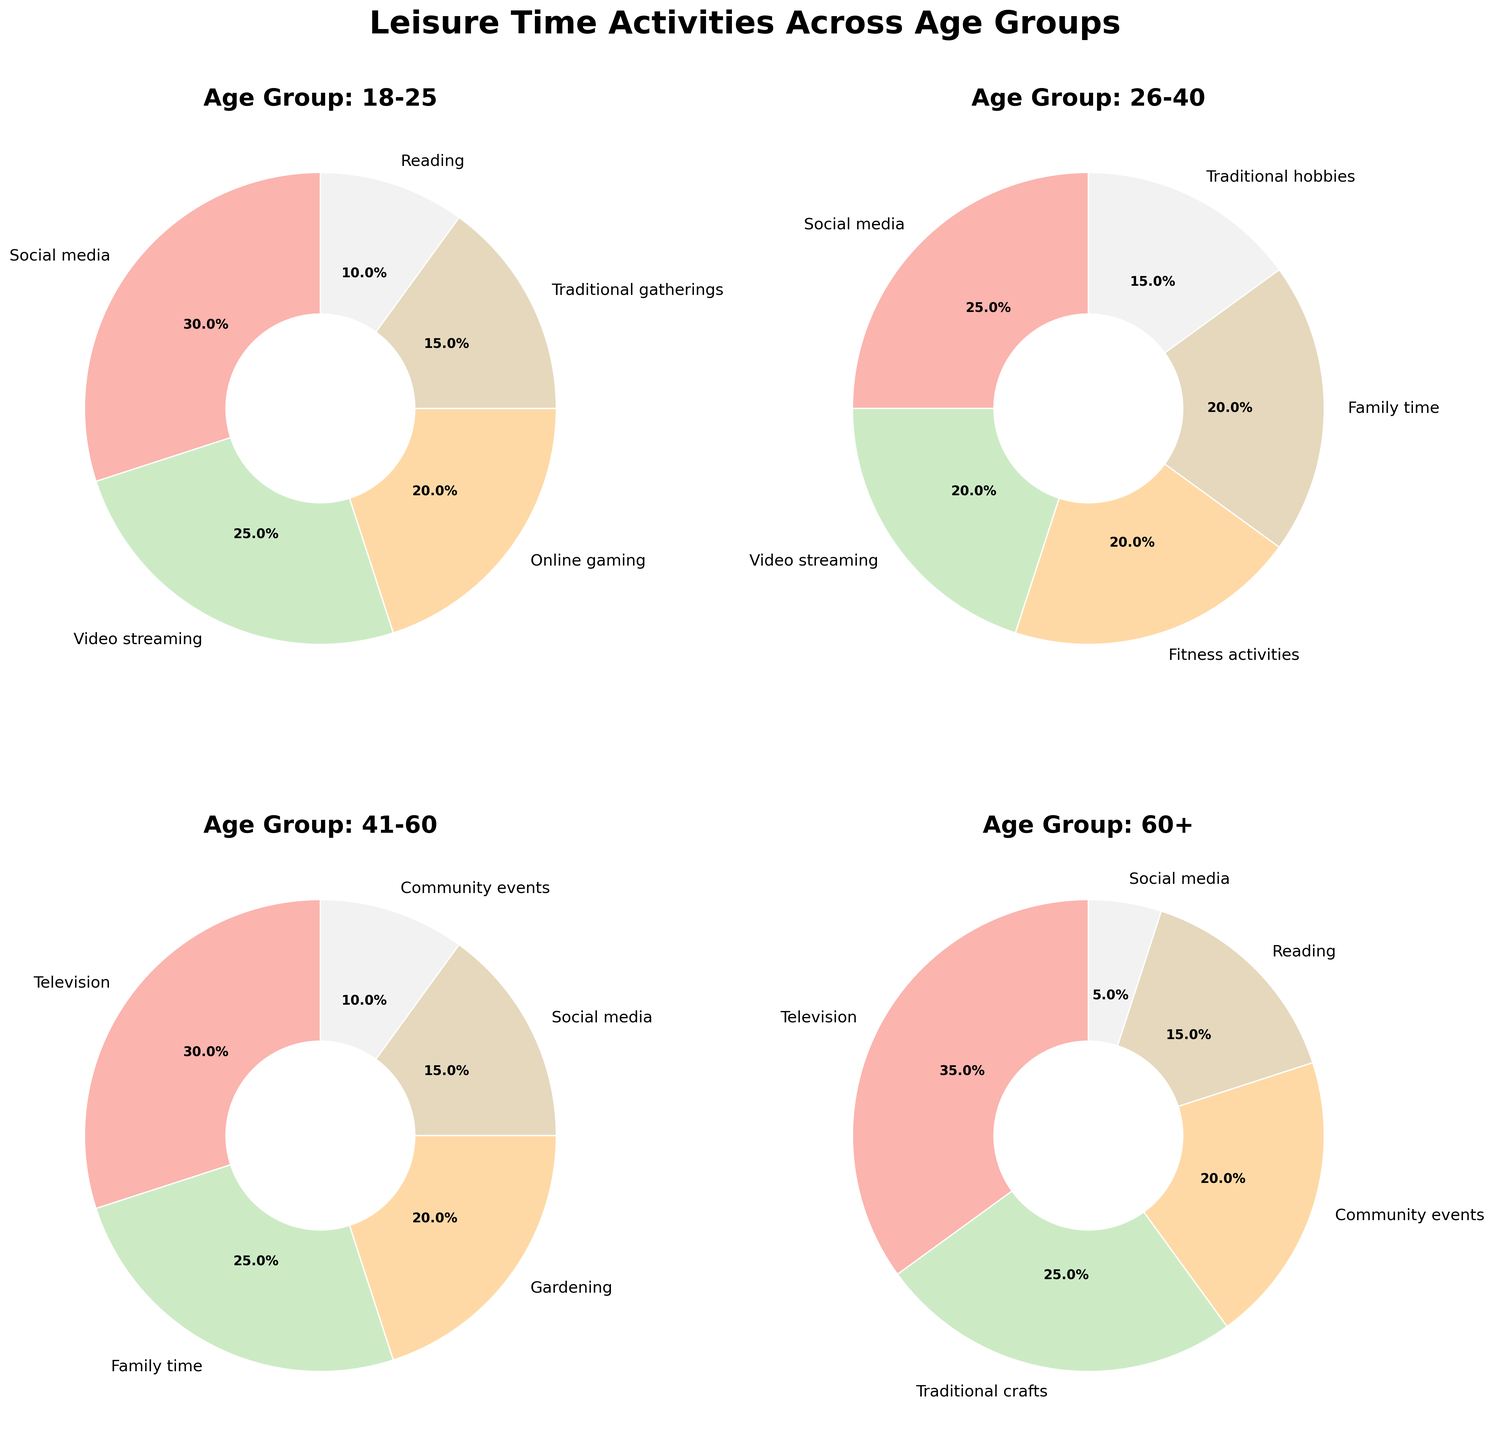Which age group spends the highest percentage of their leisure time on social media? By comparing the percentages of social media usage across the different age groups (18-25: 30%, 26-40: 25%, 41-60: 15%, 60+: 5%), it is clear that the 18-25 age group has the highest percentage.
Answer: 18-25 What is the combined percentage of leisure time spent on family time by 26-40 and 41-60 age groups? Adding the percentages for family time from both age groups (26-40: 20%, 41-60: 25%) gives a total of 45%.
Answer: 45% Which activity has the largest slice in the pie chart for the 60+ age group, and what is its percentage? Observing the chart for the 60+ age group, the largest slice represents television with a percentage of 35%.
Answer: Television, 35% Are traditional activities (gatherings, hobbies, crafts) more popular in the 18-25 group compared to the 60+ group? Comparing percentages, 18-25: Traditional gatherings (15%) / 60+: Traditional crafts (25%). The 60+ group spends a higher percentage of their time on traditional activities.
Answer: No, 60+ spends more on traditional activities What are the second most popular leisure activities for each age group? By reviewing each pie chart:
- 18-25: Video streaming (25%)
- 26-40: Video streaming, Family time, Fitness activities (20%)
- 41-60: Family time (25%)
- 60+: Traditional crafts (25%)
Answer: 18-25: Video streaming, 26-40: Video streaming, Family time, Fitness activities, 41-60: Family time, 60+: Traditional crafts Which age group allocates the least percentage to social media? By observing the social media percentages for each age group (18-25: 30%, 26-40: 25%, 41-60: 15%, 60+: 5%), the 60+ age group spends the least percentage on social media.
Answer: 60+ How much more percentage of leisure time is spent on television by the 60+ age group compared to the 41-60 age group? The 60+ age group spends 35% on television while the 41-60 age group spends 30%. The difference is 35% - 30% = 5%.
Answer: 5% Which activity has the smallest slice in the pie chart for the 18-25 age group? The smallest slice for the 18-25 age group shows reading with 10%.
Answer: Reading By how many percentage points does the 18-25 age group spend more time on social media compared to the 26-40 age group? The 18-25 age group spends 30% on social media while the 26-40 age group spends 25%. The difference is 30% - 25% = 5 percentage points.
Answer: 5 What is the total percentage of leisure time spent on activities other than social media in the 26-40 age group? Subtract the percentage of social media (25%) from the total (100%) of the 26-40 age group, which is 100% - 25% = 75%.
Answer: 75% 